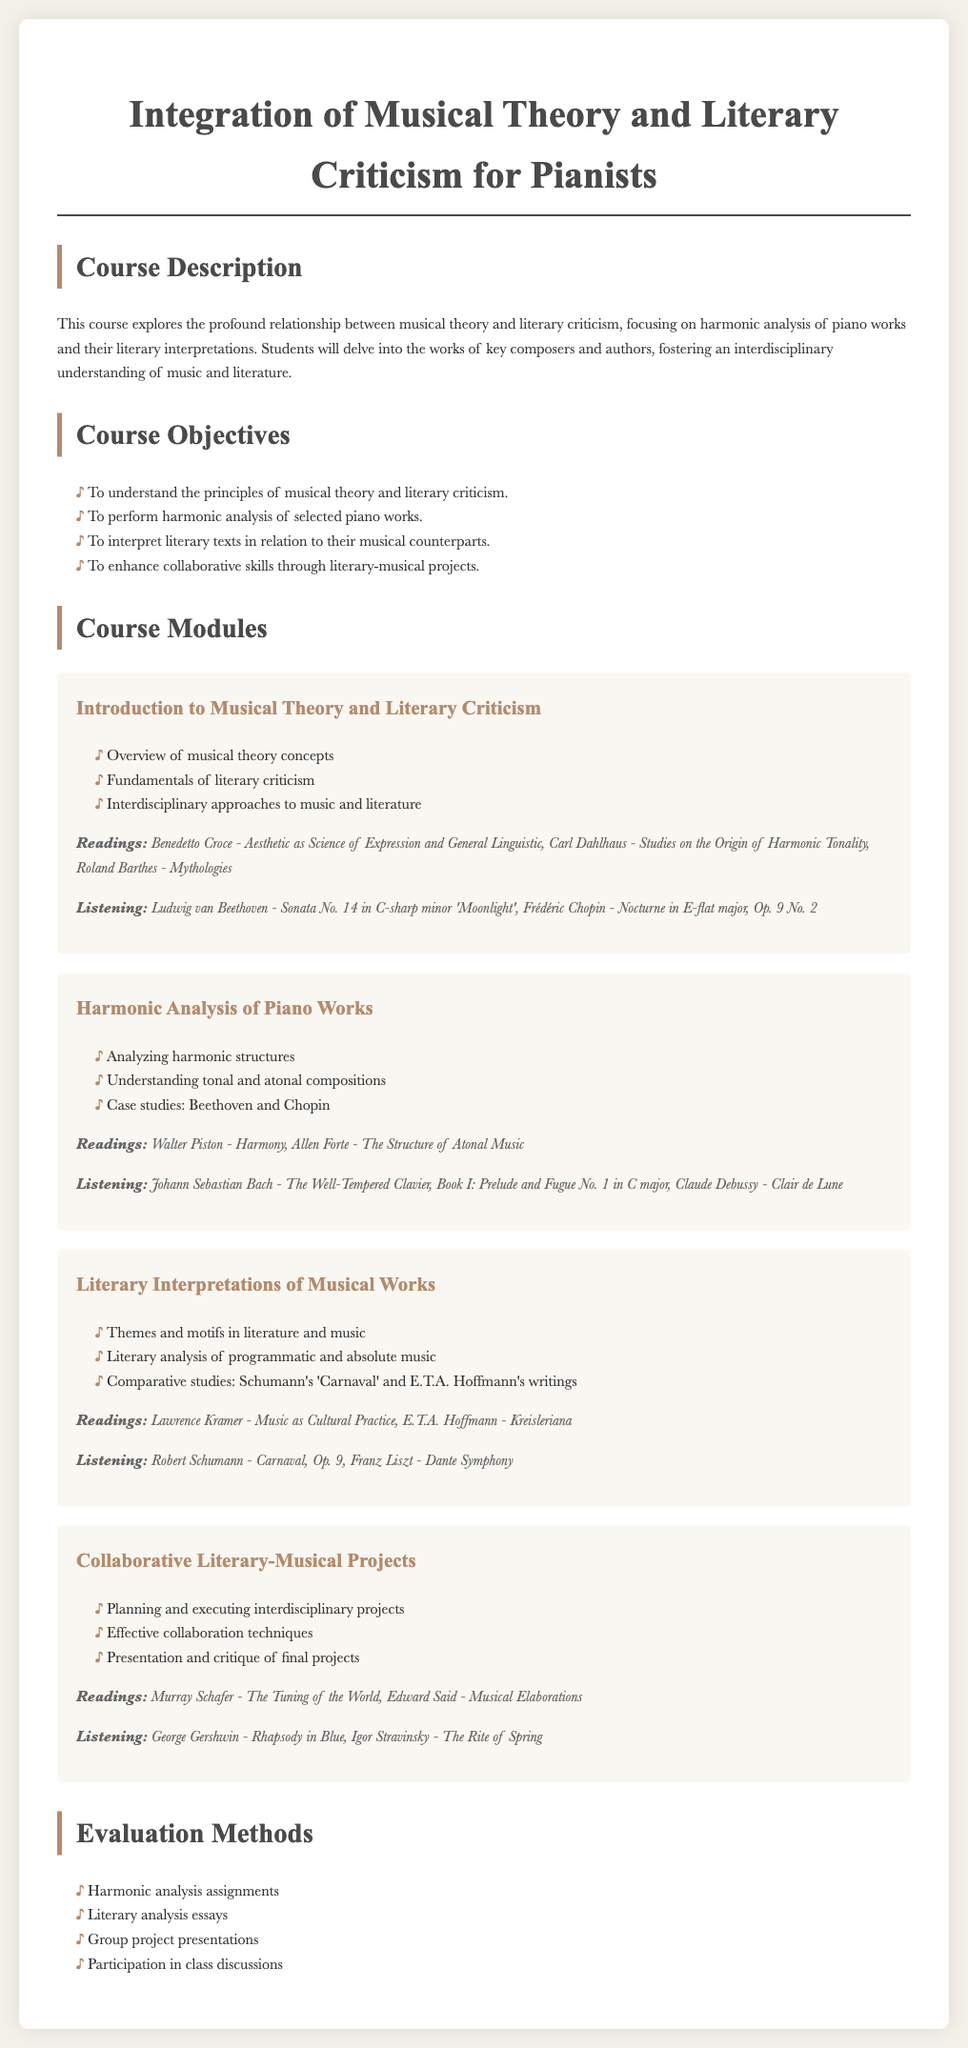what is the title of the course? The title of the course is located at the top of the document, indicating the main focus of the syllabus.
Answer: Integration of Musical Theory and Literary Criticism for Pianists how many course modules are there? The number of course modules is determined by counting the modules listed in the document.
Answer: Four who is the author of "Harmony"? The author of "Harmony" is mentioned in the reading list for the harmonic analysis module.
Answer: Walter Piston what is one listening assignment from the "Literary Interpretations of Musical Works" module? The listening assignments for each module are detailed under the respective module, answering which specific work should be listened to.
Answer: Robert Schumann - Carnaval, Op. 9 what are the evaluation methods used in the course? The evaluation methods consist of a list provided in the document outlining how students will be assessed throughout the course.
Answer: Harmonic analysis assignments, literary analysis essays, group project presentations, participation in class discussions which literary work is recommended for the "Collaborative Literary-Musical Projects" module? The document lists specific readings associated with each module, identifying key literature for students to engage with.
Answer: Murray Schafer - The Tuning of the World what is one objective of the course? The course objectives are stated as specific learning goals that students should achieve by the end of the course.
Answer: To perform harmonic analysis of selected piano works what does the "Introduction to Musical Theory and Literary Criticism" module cover? The module details the topics that will be discussed, relevant to the overarching themes of music and literature.
Answer: Overview of musical theory concepts, fundamentals of literary criticism, interdisciplinary approaches to music and literature 